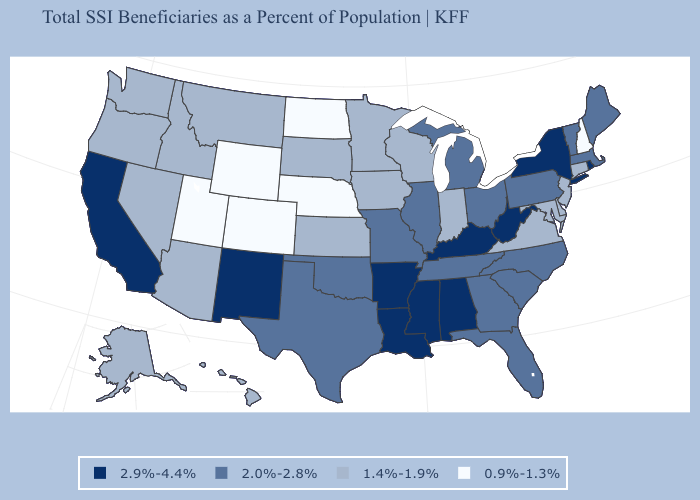What is the value of Oklahoma?
Quick response, please. 2.0%-2.8%. Name the states that have a value in the range 2.0%-2.8%?
Concise answer only. Florida, Georgia, Illinois, Maine, Massachusetts, Michigan, Missouri, North Carolina, Ohio, Oklahoma, Pennsylvania, South Carolina, Tennessee, Texas, Vermont. What is the value of Georgia?
Answer briefly. 2.0%-2.8%. Does Montana have a higher value than New Hampshire?
Quick response, please. Yes. How many symbols are there in the legend?
Answer briefly. 4. Which states have the lowest value in the South?
Keep it brief. Delaware, Maryland, Virginia. Does Kansas have the lowest value in the USA?
Be succinct. No. Among the states that border Iowa , does Nebraska have the lowest value?
Write a very short answer. Yes. What is the lowest value in the USA?
Keep it brief. 0.9%-1.3%. Does Iowa have the highest value in the MidWest?
Concise answer only. No. Among the states that border Illinois , which have the highest value?
Keep it brief. Kentucky. Does the map have missing data?
Be succinct. No. What is the value of Minnesota?
Answer briefly. 1.4%-1.9%. Name the states that have a value in the range 2.9%-4.4%?
Keep it brief. Alabama, Arkansas, California, Kentucky, Louisiana, Mississippi, New Mexico, New York, Rhode Island, West Virginia. Name the states that have a value in the range 1.4%-1.9%?
Concise answer only. Alaska, Arizona, Connecticut, Delaware, Hawaii, Idaho, Indiana, Iowa, Kansas, Maryland, Minnesota, Montana, Nevada, New Jersey, Oregon, South Dakota, Virginia, Washington, Wisconsin. 